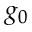Convert formula to latex. <formula><loc_0><loc_0><loc_500><loc_500>g _ { 0 }</formula> 